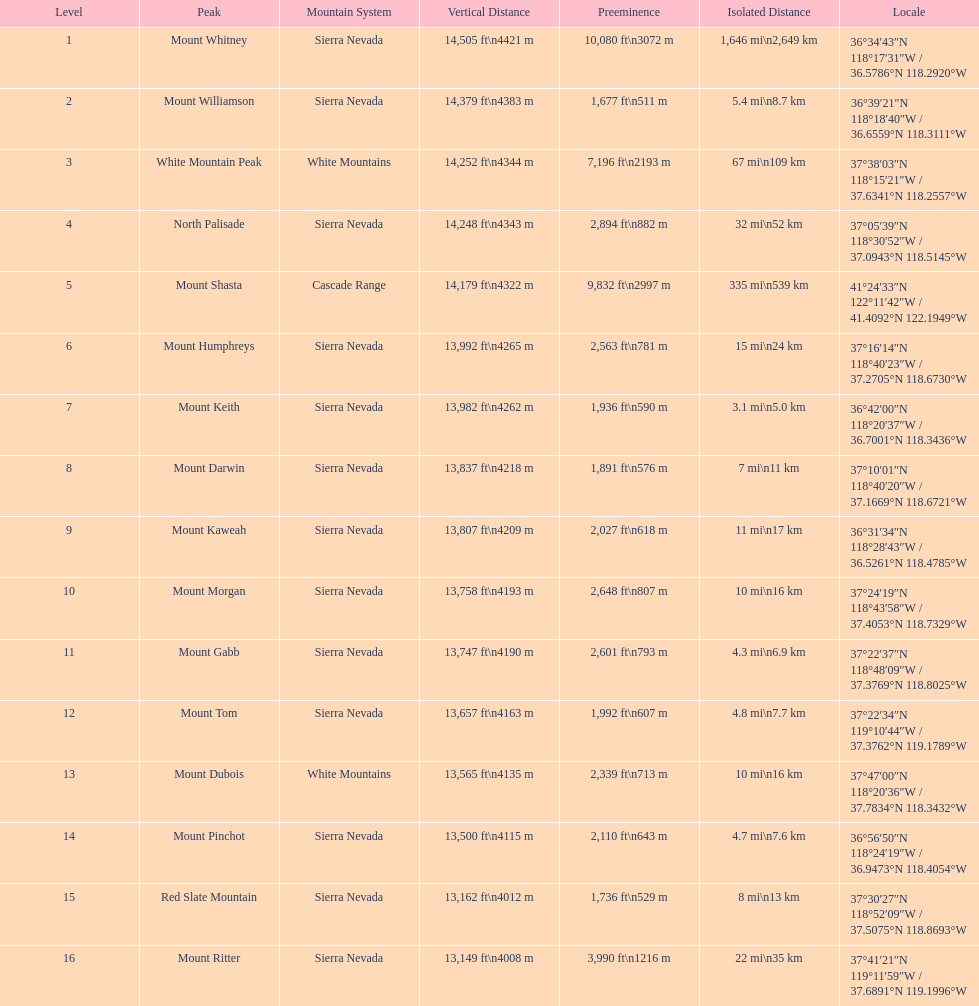Comparing the peaks of mount keith and north palisade, which one is higher? Below. 